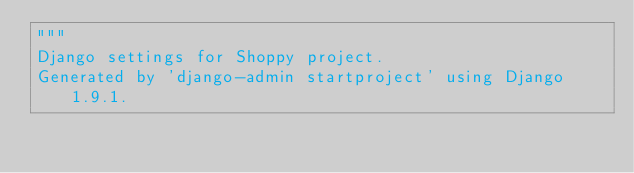Convert code to text. <code><loc_0><loc_0><loc_500><loc_500><_Python_>"""
Django settings for Shoppy project.
Generated by 'django-admin startproject' using Django 1.9.1.</code> 